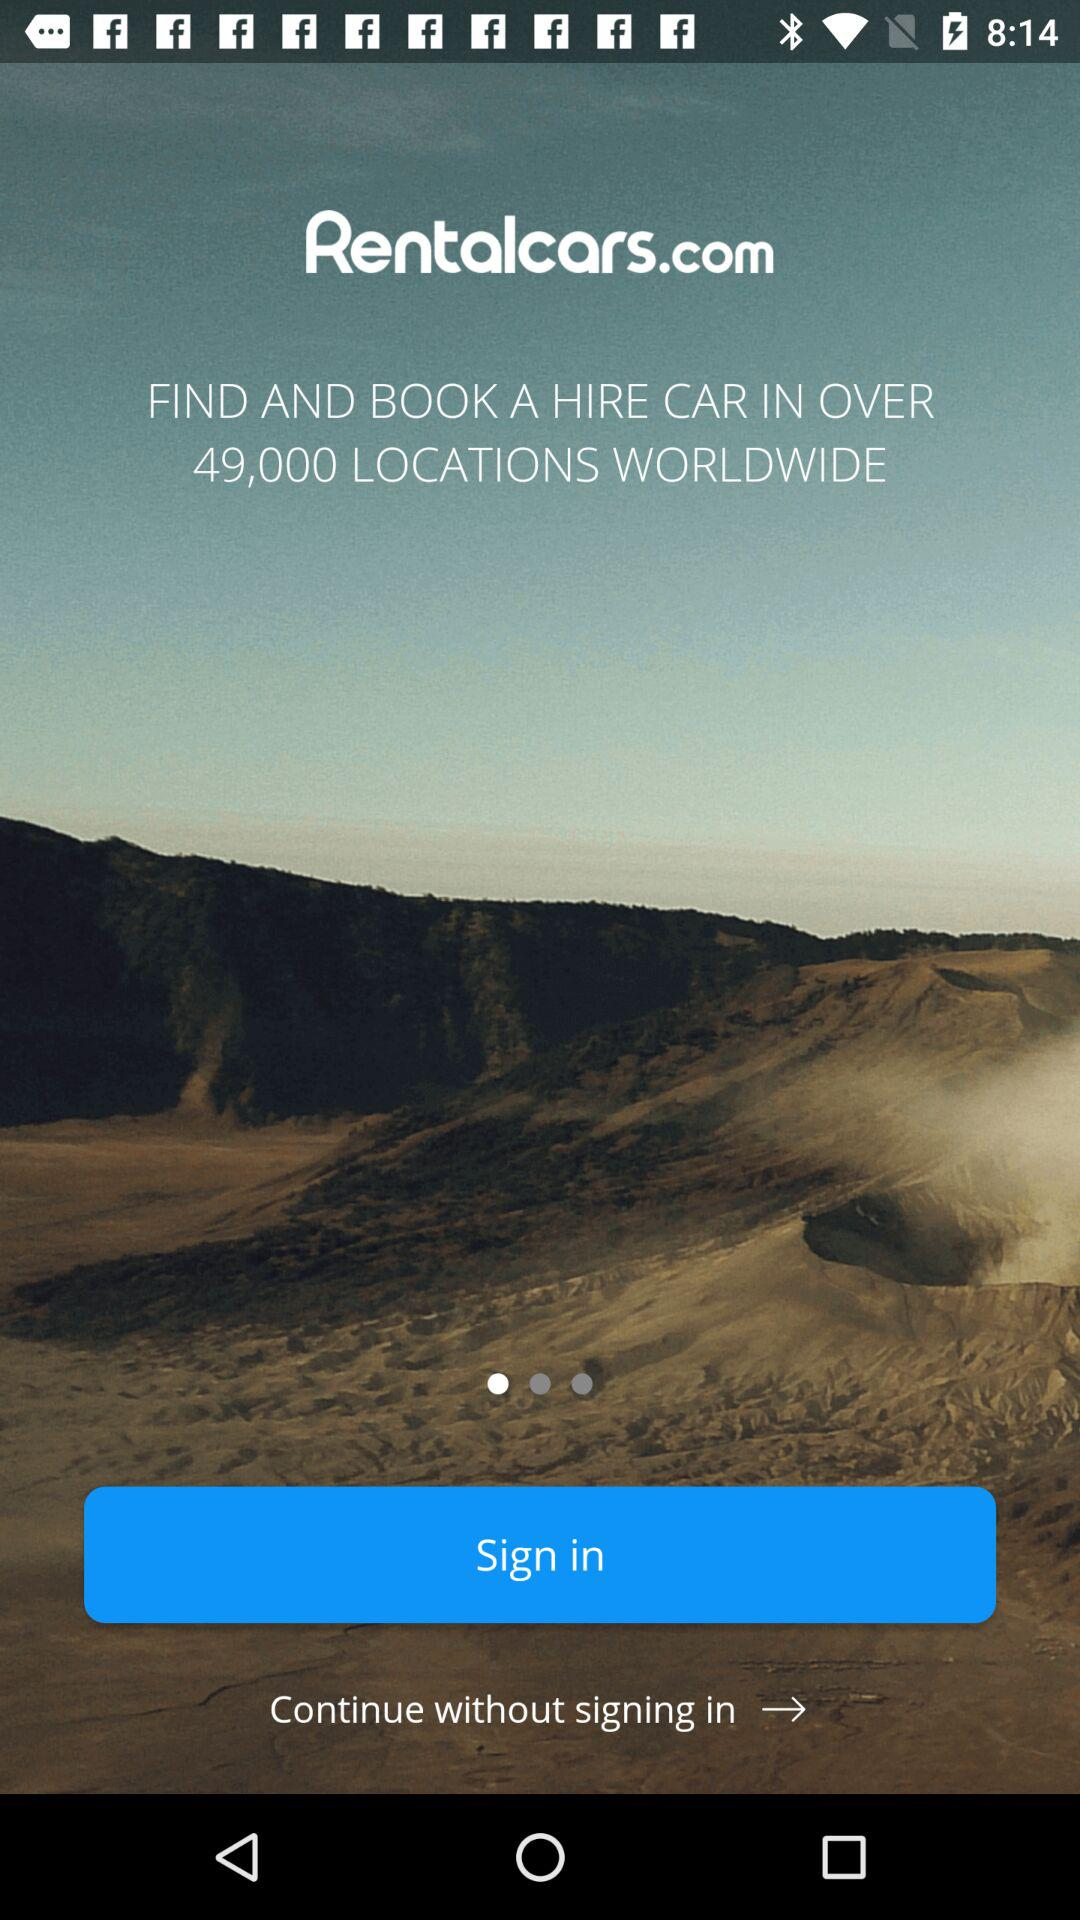What is the app name? The app name is "Rentalcars.com". 